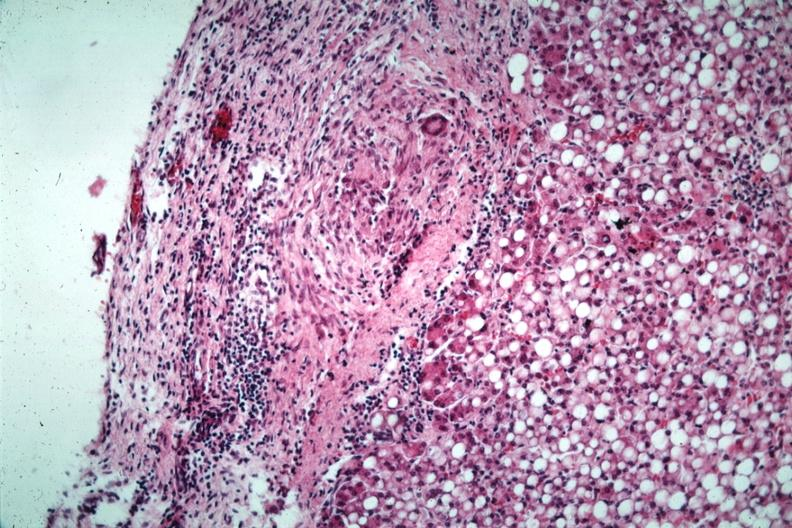what is present?
Answer the question using a single word or phrase. Peritoneum 